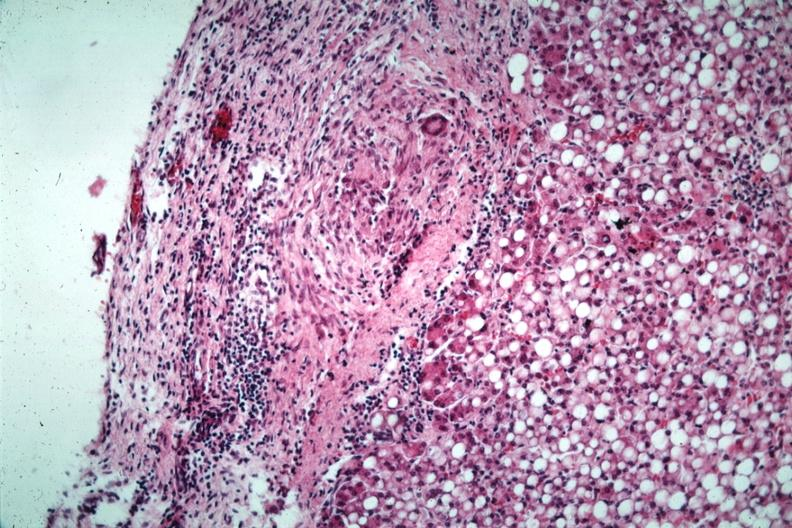what is present?
Answer the question using a single word or phrase. Peritoneum 